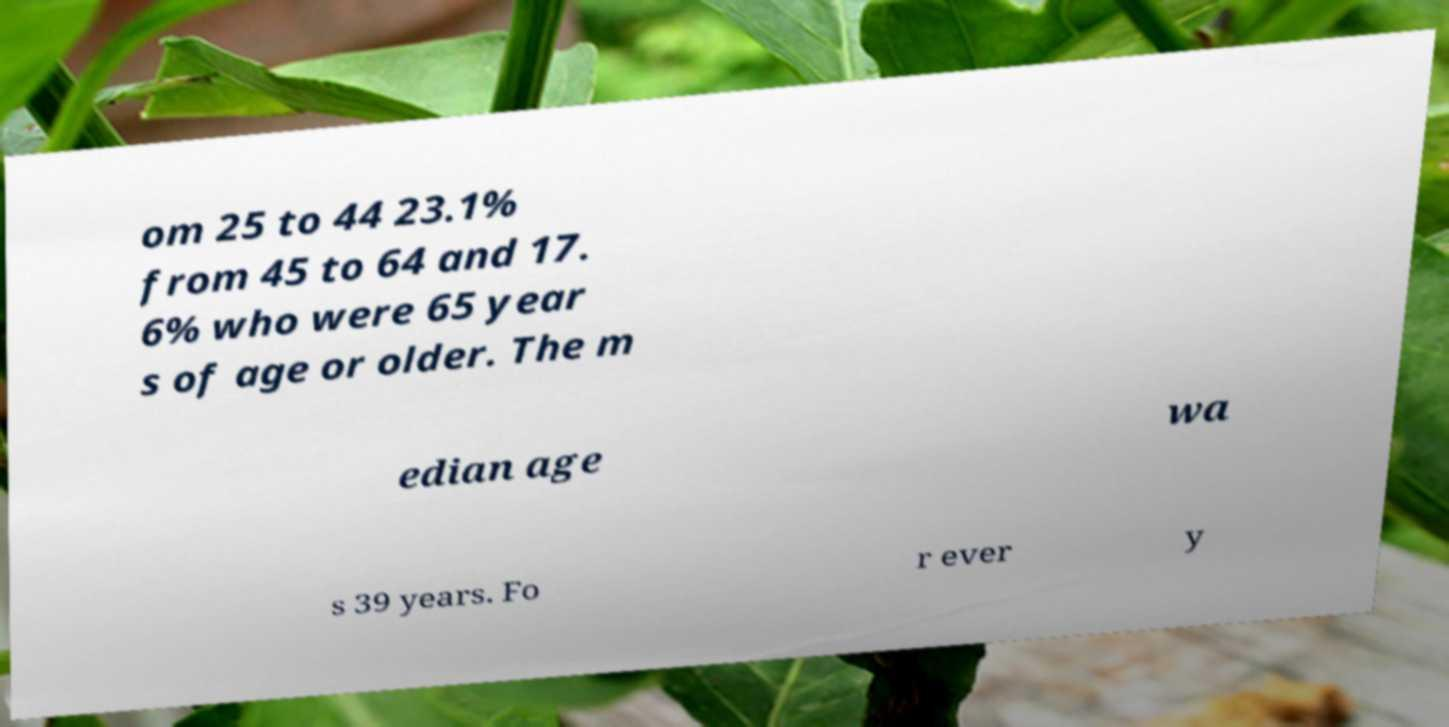Please identify and transcribe the text found in this image. om 25 to 44 23.1% from 45 to 64 and 17. 6% who were 65 year s of age or older. The m edian age wa s 39 years. Fo r ever y 